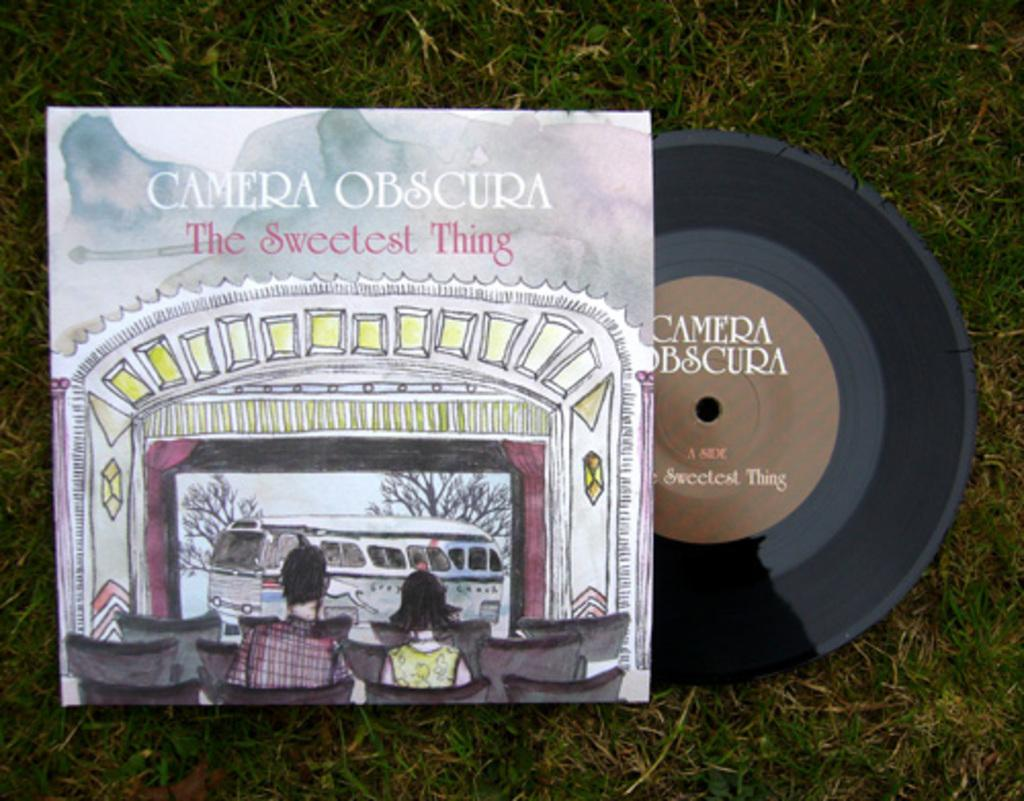What object is present in the image that is circular in shape? There is a disc in the image. What is covering the disc in the image? There is a disc-cover in the image. Where are the disc and disc-cover located? The disc and disc-cover are on the grass. How many people are on the disc-cover? There are two people on the disc-cover. What can be seen on the disc-cover besides the people? There is a vehicle and a tree visible on the disc-cover. Is there any text or markings on the disc-cover? Yes, there is writing on the disc-cover. What type of quill is being used by the people on the disc-cover to write on the bun? There is no quill or bun present in the image. How many members are on the team visible on the disc-cover? There is no team visible on the disc-cover; only two people are present. 